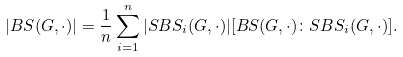<formula> <loc_0><loc_0><loc_500><loc_500>| B S ( G , \cdot ) | = \frac { 1 } { n } \sum _ { i = 1 } ^ { n } | S B S _ { i } ( G , \cdot ) | [ B S ( G , \cdot ) \colon S B S _ { i } ( G , \cdot ) ] .</formula> 